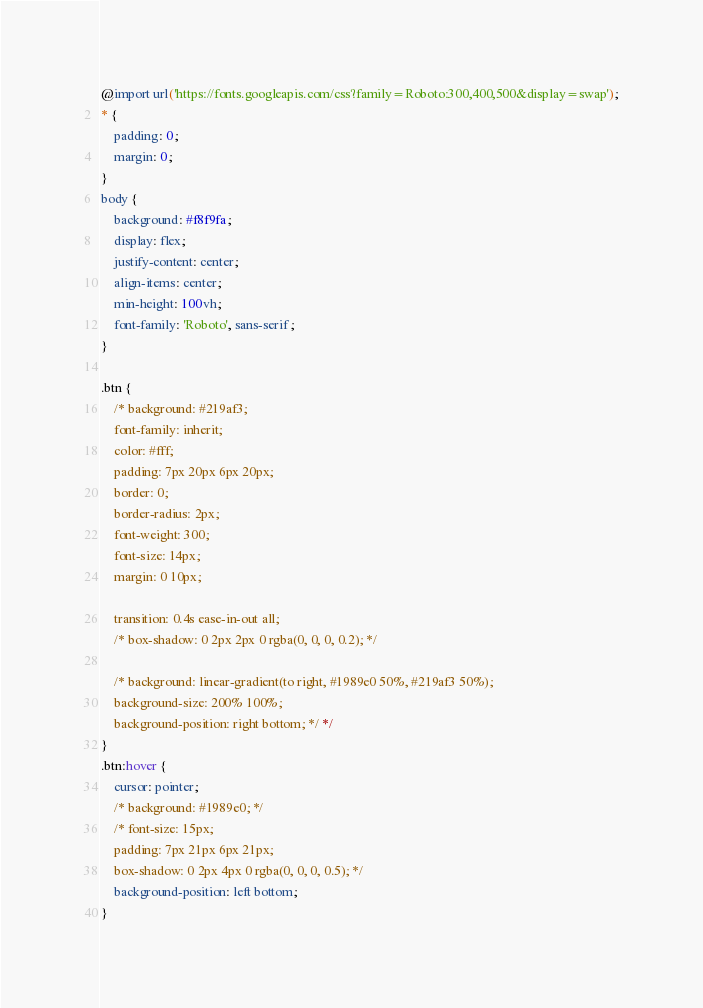<code> <loc_0><loc_0><loc_500><loc_500><_CSS_>@import url('https://fonts.googleapis.com/css?family=Roboto:300,400,500&display=swap');
* {
	padding: 0;
	margin: 0;
}
body {
	background: #f8f9fa;
	display: flex;
	justify-content: center;
	align-items: center;
	min-height: 100vh;
	font-family: 'Roboto', sans-serif;
}

.btn {
	/* background: #219af3;
	font-family: inherit;
	color: #fff;
	padding: 7px 20px 6px 20px;
	border: 0;
	border-radius: 2px;
	font-weight: 300;
	font-size: 14px;
	margin: 0 10px;

	transition: 0.4s ease-in-out all;
	/* box-shadow: 0 2px 2px 0 rgba(0, 0, 0, 0.2); */

	/* background: linear-gradient(to right, #1989e0 50%, #219af3 50%);
	background-size: 200% 100%;
	background-position: right bottom; */ */
}
.btn:hover {
	cursor: pointer;
	/* background: #1989e0; */
	/* font-size: 15px;
	padding: 7px 21px 6px 21px;
	box-shadow: 0 2px 4px 0 rgba(0, 0, 0, 0.5); */
	background-position: left bottom;
}
</code> 